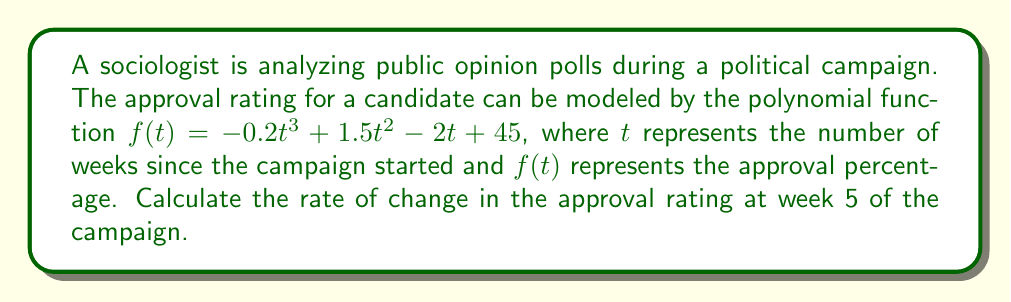Can you answer this question? To find the rate of change at a specific point, we need to calculate the derivative of the function and evaluate it at the given point.

Step 1: Find the derivative of $f(t)$.
$f'(t) = \frac{d}{dt}(-0.2t^3 + 1.5t^2 - 2t + 45)$
$f'(t) = -0.6t^2 + 3t - 2$

Step 2: Evaluate the derivative at $t = 5$.
$f'(5) = -0.6(5)^2 + 3(5) - 2$
$f'(5) = -0.6(25) + 15 - 2$
$f'(5) = -15 + 15 - 2$
$f'(5) = -2$

The rate of change at week 5 is -2 percentage points per week.
Answer: -2 percentage points/week 